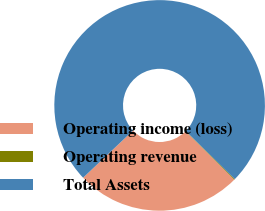Convert chart to OTSL. <chart><loc_0><loc_0><loc_500><loc_500><pie_chart><fcel>Operating income (loss)<fcel>Operating revenue<fcel>Total Assets<nl><fcel>25.49%<fcel>0.11%<fcel>74.4%<nl></chart> 